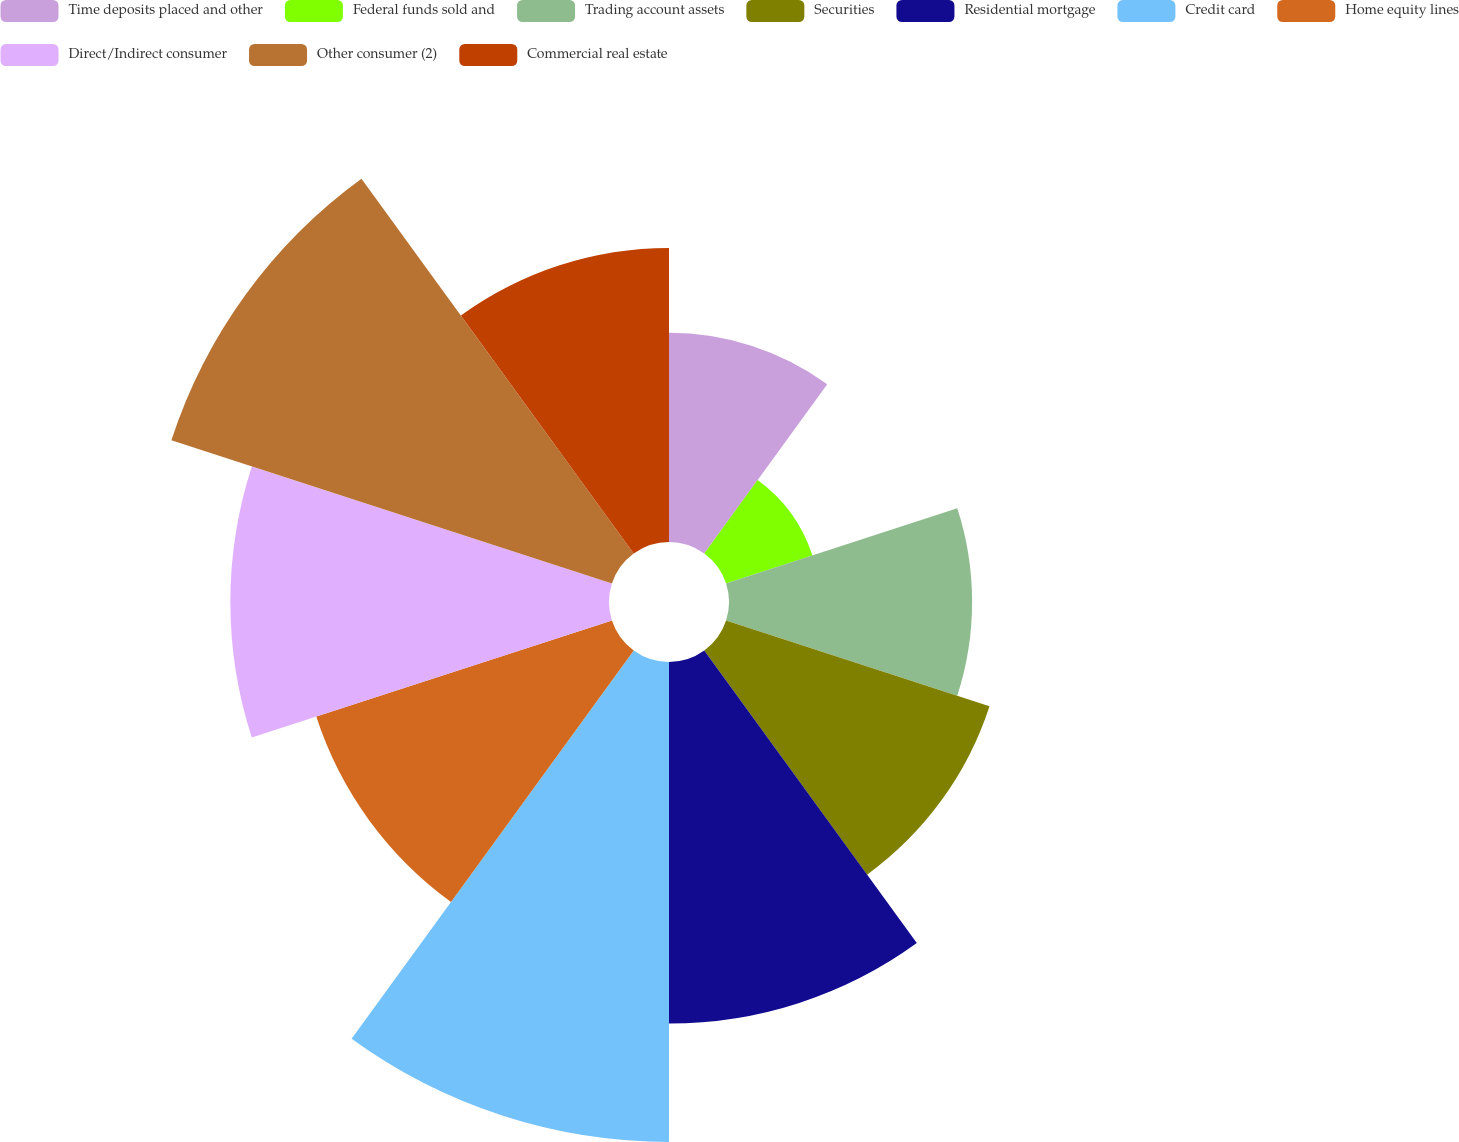Convert chart to OTSL. <chart><loc_0><loc_0><loc_500><loc_500><pie_chart><fcel>Time deposits placed and other<fcel>Federal funds sold and<fcel>Trading account assets<fcel>Securities<fcel>Residential mortgage<fcel>Credit card<fcel>Home equity lines<fcel>Direct/Indirect consumer<fcel>Other consumer (2)<fcel>Commercial real estate<nl><fcel>6.73%<fcel>2.92%<fcel>7.82%<fcel>8.91%<fcel>11.63%<fcel>15.44%<fcel>10.0%<fcel>12.18%<fcel>14.9%<fcel>9.46%<nl></chart> 